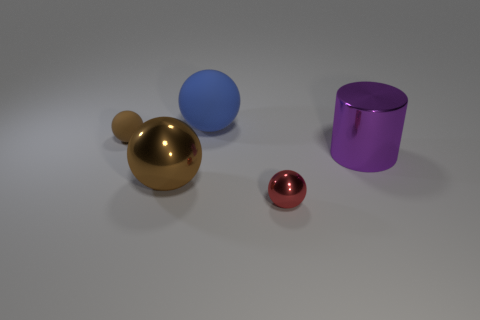There is a large ball that is the same color as the small matte ball; what is it made of?
Offer a very short reply. Metal. Are there more big brown rubber blocks than purple metal cylinders?
Provide a succinct answer. No. There is a small sphere on the left side of the large blue rubber sphere; what is its color?
Your answer should be compact. Brown. How big is the ball that is in front of the large matte object and on the right side of the large metal sphere?
Offer a very short reply. Small. What number of matte spheres are the same size as the blue object?
Offer a very short reply. 0. What is the material of the other large thing that is the same shape as the brown metallic object?
Provide a succinct answer. Rubber. Is the shape of the large brown object the same as the purple object?
Give a very brief answer. No. How many small metallic things are behind the small red ball?
Give a very brief answer. 0. What is the shape of the thing that is left of the brown object in front of the big metallic cylinder?
Ensure brevity in your answer.  Sphere. What shape is the big purple thing that is the same material as the small red object?
Keep it short and to the point. Cylinder. 